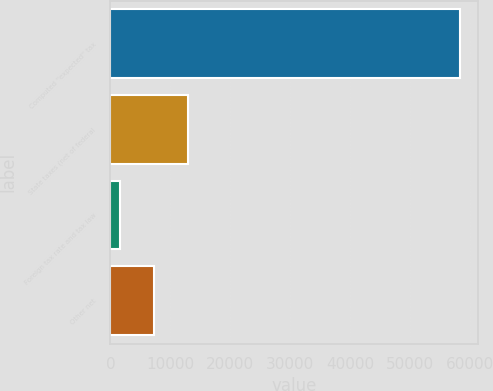Convert chart. <chart><loc_0><loc_0><loc_500><loc_500><bar_chart><fcel>Computed ''expected'' tax<fcel>State taxes (net of federal<fcel>Foreign tax rate and tax law<fcel>Other net<nl><fcel>58357<fcel>12938.6<fcel>1584<fcel>7261.3<nl></chart> 